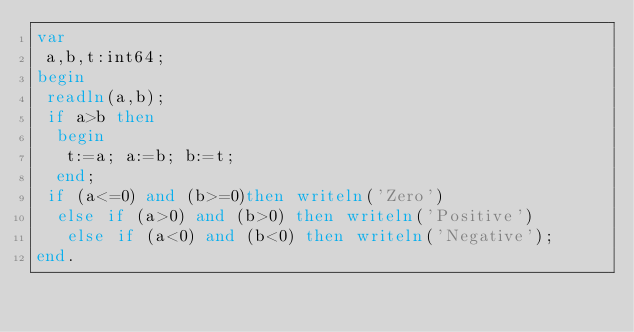<code> <loc_0><loc_0><loc_500><loc_500><_Pascal_>var
 a,b,t:int64;
begin
 readln(a,b);
 if a>b then
  begin
   t:=a; a:=b; b:=t;
  end;
 if (a<=0) and (b>=0)then writeln('Zero')
  else if (a>0) and (b>0) then writeln('Positive')
   else if (a<0) and (b<0) then writeln('Negative');
end.</code> 